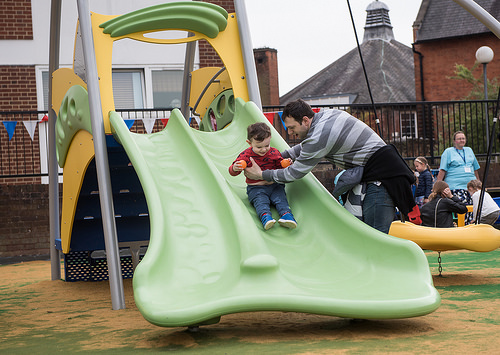<image>
Can you confirm if the boy is on the slide? Yes. Looking at the image, I can see the boy is positioned on top of the slide, with the slide providing support. Is there a slide next to the child? No. The slide is not positioned next to the child. They are located in different areas of the scene. 